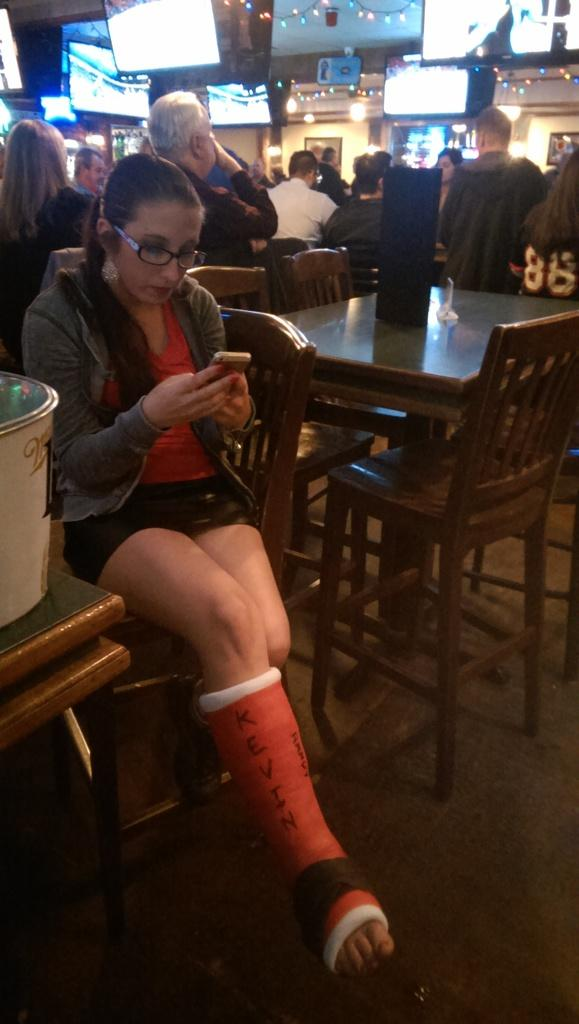What is the woman in the image doing? The woman is sitting in a chair in the image. What is the woman holding in her hand? The woman is holding a mobile in her hand. Where is the woman located in the image? The woman is in a restaurant, as there are people behind her. What type of polish is the woman applying to her nails in the image? There is no indication in the image that the woman is applying polish to her nails, as she is holding a mobile in her hand. 